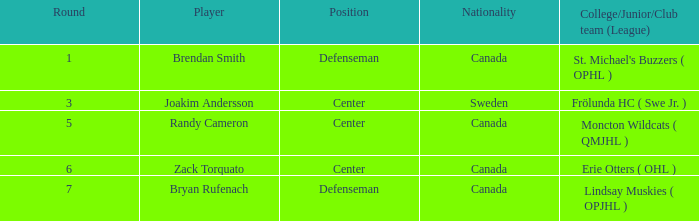Where does center Joakim Andersson come from? Sweden. 